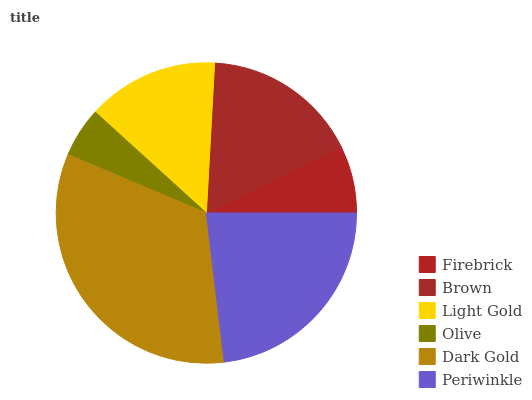Is Olive the minimum?
Answer yes or no. Yes. Is Dark Gold the maximum?
Answer yes or no. Yes. Is Brown the minimum?
Answer yes or no. No. Is Brown the maximum?
Answer yes or no. No. Is Brown greater than Firebrick?
Answer yes or no. Yes. Is Firebrick less than Brown?
Answer yes or no. Yes. Is Firebrick greater than Brown?
Answer yes or no. No. Is Brown less than Firebrick?
Answer yes or no. No. Is Brown the high median?
Answer yes or no. Yes. Is Light Gold the low median?
Answer yes or no. Yes. Is Periwinkle the high median?
Answer yes or no. No. Is Olive the low median?
Answer yes or no. No. 